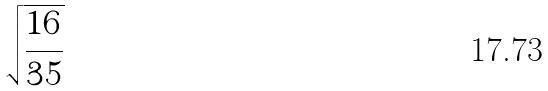<formula> <loc_0><loc_0><loc_500><loc_500>\sqrt { \frac { 1 6 } { 3 5 } }</formula> 